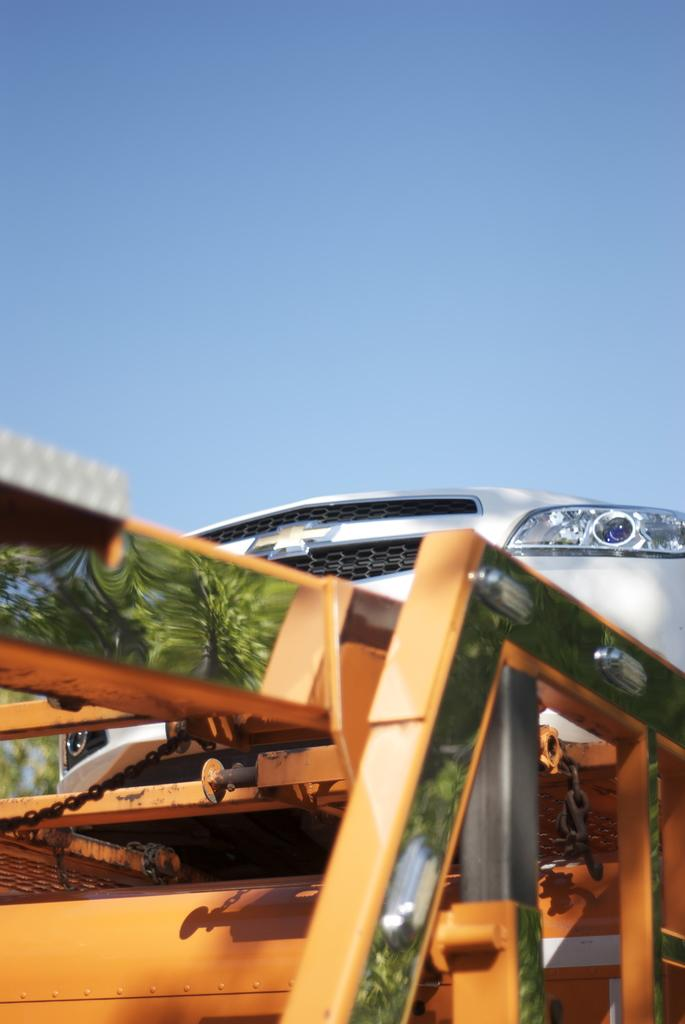What is the main subject of the image? The main subject of the image is a car. What is the car's current situation in the image? The car is on a towing vehicle. What type of window is visible in the image? There is no window visible in the image; it features a car being towed by a towing vehicle. 